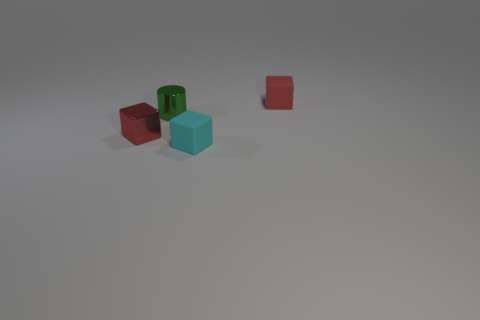What material is the small cyan thing that is the same shape as the red metallic thing?
Make the answer very short. Rubber. How many objects are cubes to the right of the cyan rubber cube or big brown blocks?
Your answer should be very brief. 1. The red object that is the same material as the small cyan cube is what shape?
Your answer should be very brief. Cube. How many small red rubber objects are the same shape as the cyan thing?
Give a very brief answer. 1. What is the material of the cyan block?
Provide a short and direct response. Rubber. There is a shiny cube; is its color the same as the rubber thing that is behind the metallic cube?
Your response must be concise. Yes. What number of spheres are either tiny green metal objects or purple objects?
Offer a terse response. 0. There is a small cube behind the metallic cylinder; what color is it?
Keep it short and to the point. Red. What shape is the tiny rubber object that is the same color as the small shiny block?
Make the answer very short. Cube. What number of cyan objects have the same size as the metallic cylinder?
Your response must be concise. 1. 